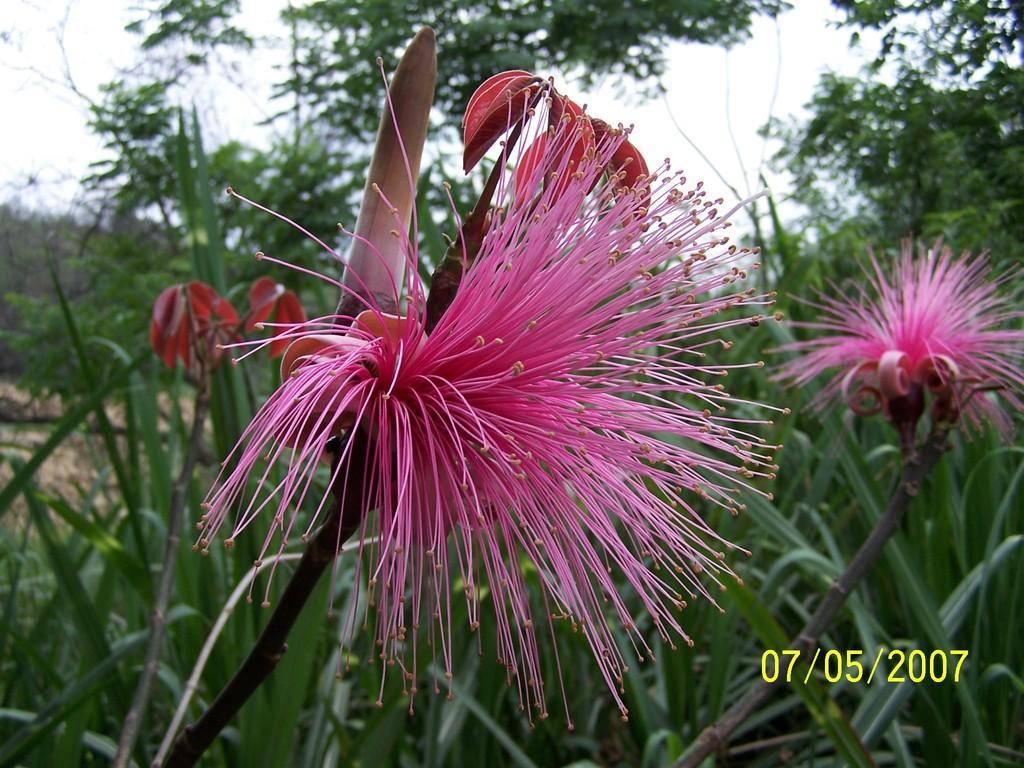In one or two sentences, can you explain what this image depicts? In the background we can see the sky, trees. In this picture we can see the flowers and the plants. In the bottom right corner of the picture we can see the date. 